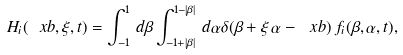Convert formula to latex. <formula><loc_0><loc_0><loc_500><loc_500>H _ { i } ( \ x b , \xi , t ) = \int _ { - 1 } ^ { 1 } \, d \beta \int _ { - 1 + | \beta | } ^ { 1 - | \beta | } \, d \alpha \delta ( \beta + \xi \, \alpha - \ x b ) \, f _ { i } ( \beta , \alpha , t ) ,</formula> 